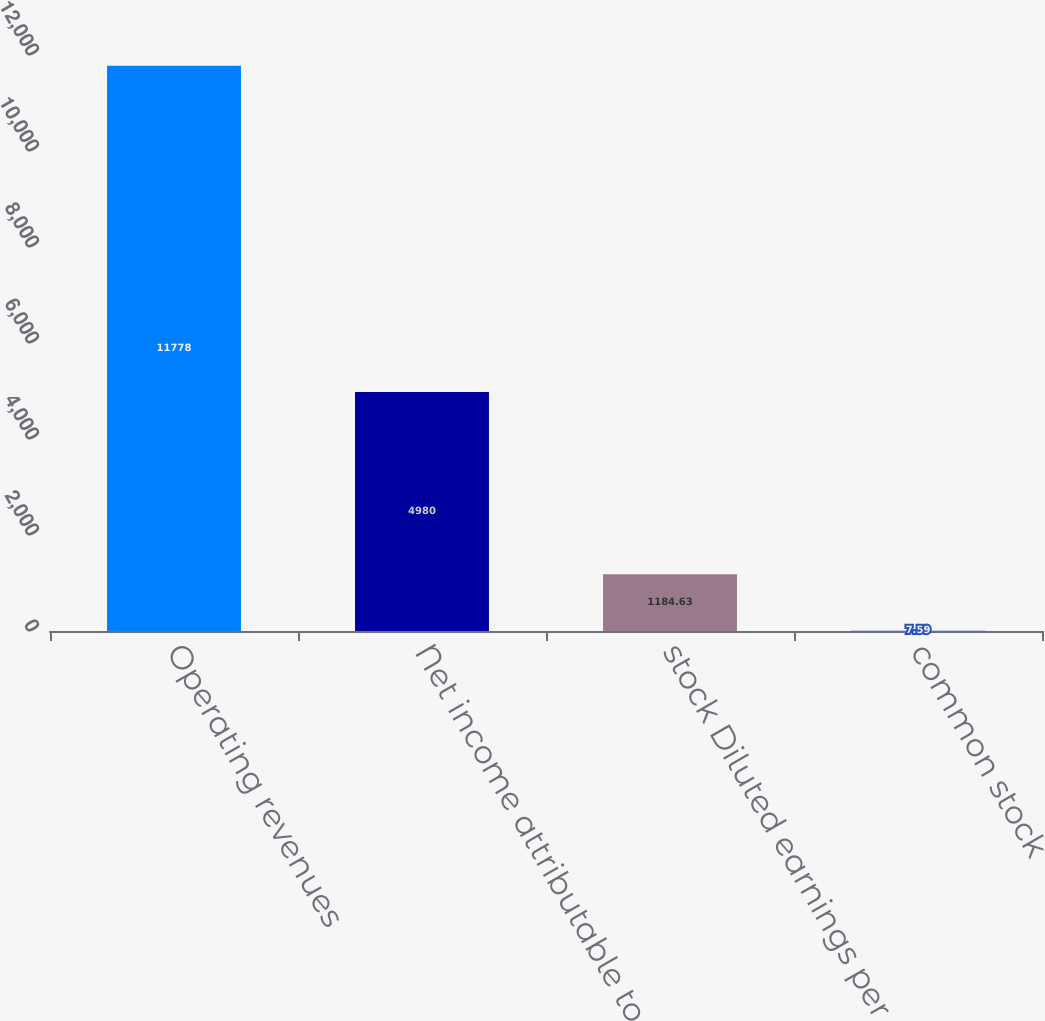<chart> <loc_0><loc_0><loc_500><loc_500><bar_chart><fcel>Operating revenues<fcel>Net income attributable to<fcel>stock Diluted earnings per<fcel>common stock<nl><fcel>11778<fcel>4980<fcel>1184.63<fcel>7.59<nl></chart> 